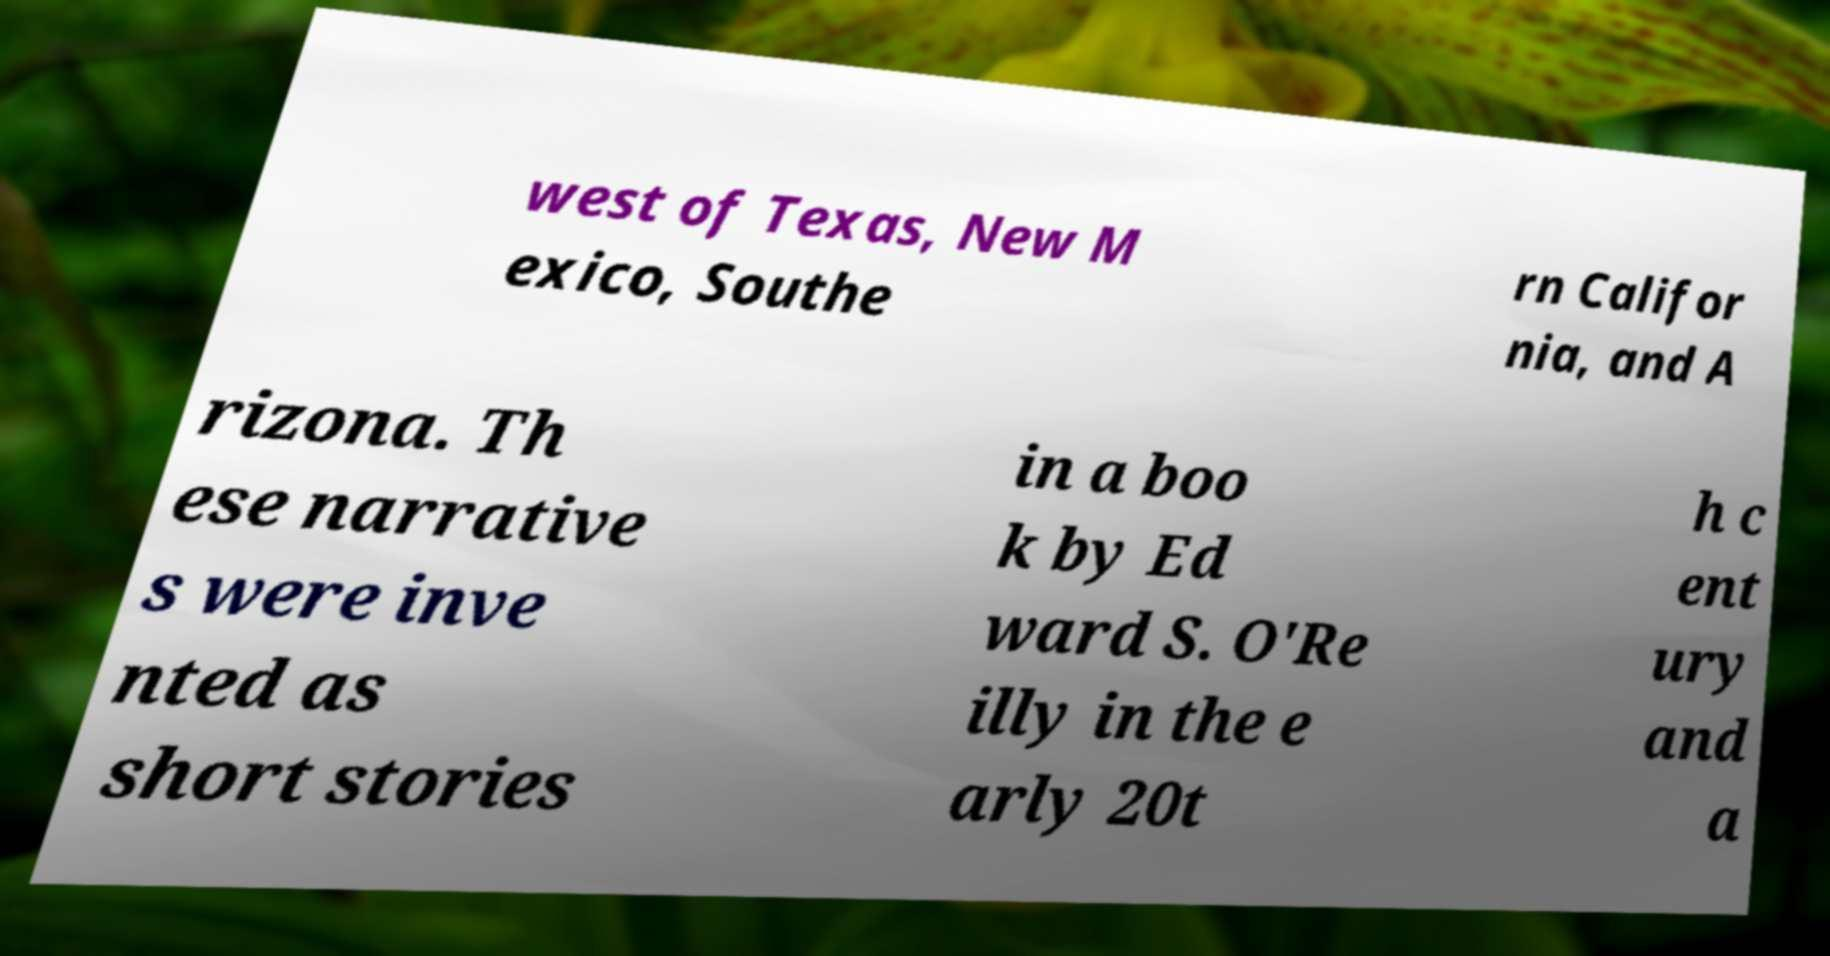There's text embedded in this image that I need extracted. Can you transcribe it verbatim? west of Texas, New M exico, Southe rn Califor nia, and A rizona. Th ese narrative s were inve nted as short stories in a boo k by Ed ward S. O'Re illy in the e arly 20t h c ent ury and a 